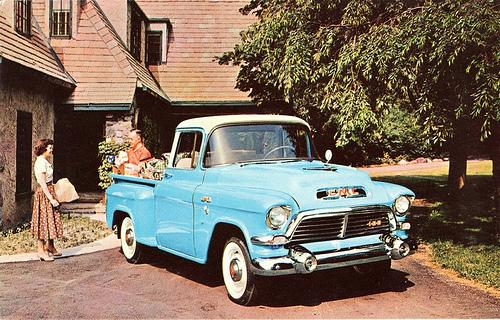Mention the relationship between the man and the woman standing in front of the house. The man is bringing home groceries to his wife. Describe the tree and its surroundings in the image. The tree is big and stands beside the car, while its shadow is cast on the ground. What is the approximate time period in which this picture was taken? The picture was taken during the middle 1900s. Analyze the interaction between the objects and the people in the image. The woman is standing in the driveway, and the man is behind the truck holding groceries, both are talking to each other, possibly discussing the groceries or the truck. What is the most prominent feature of the house in the image? The house's most prominent feature is its big size. What is the man holding in his hands, and what is he wearing? The man is holding groceries and wearing an orange shirt. How many people are there in the image, and what are they doing? There are two people in the image: a man holding groceries and a woman standing, both are talking. Describe the woman's appearance and attire in the image. The woman is wearing a patterned dress with a light-colored blouse, and she looks happy. Identify the key features of the blue truck in the image. The blue truck has a manufacturer logo, right and left headlights, front right wheel, grill, windshield, front bumper, and white walls. Identify the color and type of the vehicle in the image. The vehicle is a light blue pickup truck. Assess the quality of this image taken during the middle 1900s. The quality is typical for the time period and preserves intricate details on the objects. State the color of the truck that dominates the image. Light blue. Is there a group of people standing by the house? The image information only mentions two people, not a group. An interrogative sentence may cause confusion and make the viewer search for additional people. Detect any text or logos that might serve as an identifier for the truck. The logo on the front of the truck located at X:314 Y:185 Width:55 Height:55. Identify any anomalies in this image from the middle 1900s. There are no apparent anomalies in the image. Indicate the tree's shadow dimensions and location in the image. X:376 Y:173 Width:122 Height:122 Can you spot a red ball on the lawn beside the blue truck? There is no mention of a red ball or any other ball in the given information. Using an interrogative sentence to ask about a non-existent object may mislead the viewer. How would you describe the sentiment of this image, based on the people and the setting? The sentiment is warm and nostalgic. A small dog is playing near the parked car. No, it's not mentioned in the image. Can you find a bicycle leaning against the tree? There is no mention of a bicycle in the given image information. Using an interrogative sentence to question the viewer may make them search for a non-existent object. What object is at position X:316 Y:187 and measures Width:49 Height:49? A blue truck's manufacturer logo. Out of these options, which best describes the man's activity: sitting, talking, or sleeping? Talking The woman is carrying an umbrella in her hand. There is no mention of an umbrella in the provided information. A declarative sentence might make the viewer believe that they should see an umbrella in the woman's hand. What color is the dress that the woman is wearing? The dress has a pattern, but the main color is not specified. Describe the scene in this old family picture. A man holding groceries and a woman in a dress and white blouse stand by a light blue GMC pickup truck, parked by a big house with a large tree in the yard. A beautiful flower garden surrounds the house. There is no mention of a flower garden in the image information. A declarative sentence might lead the viewer to expect a garden around the house, causing confusion when it's not there. Evaluate the visual quality of the family picture. Average quality with preserved details on objects and characters. Describe the overall emotion or atmosphere expressed by this middle 1900s image. Nostalgic, warm, and friendly. Which vehicle is the focus of this image? A blue car, a red car, or a blue pickup truck? A blue pickup truck. What pattern or design can be found on the woman's dress in the image? There is a pattern on the dress, but the specific design is not described. Determine the objects located at X:166 Y:127 Width:43 Height:43 within the image. The window of the car. Identify the object referred to as "an orange shirt on the man." X:118 Y:145 Width:34 Height:34 What separates the man and the woman in terms of position and objects in the image? The blue GMC pickup truck. Analyze the interaction between the man holding groceries and the woman near the truck in the image. The interaction seems friendly, and they appear to be having a conversation. Find the location and size of the woman's blouse in the image. X:29 Y:154 Width:27 Height:27 What attributes can you identify of the woman's dress? The dress has a pattern and covers the woman up to her neck. 